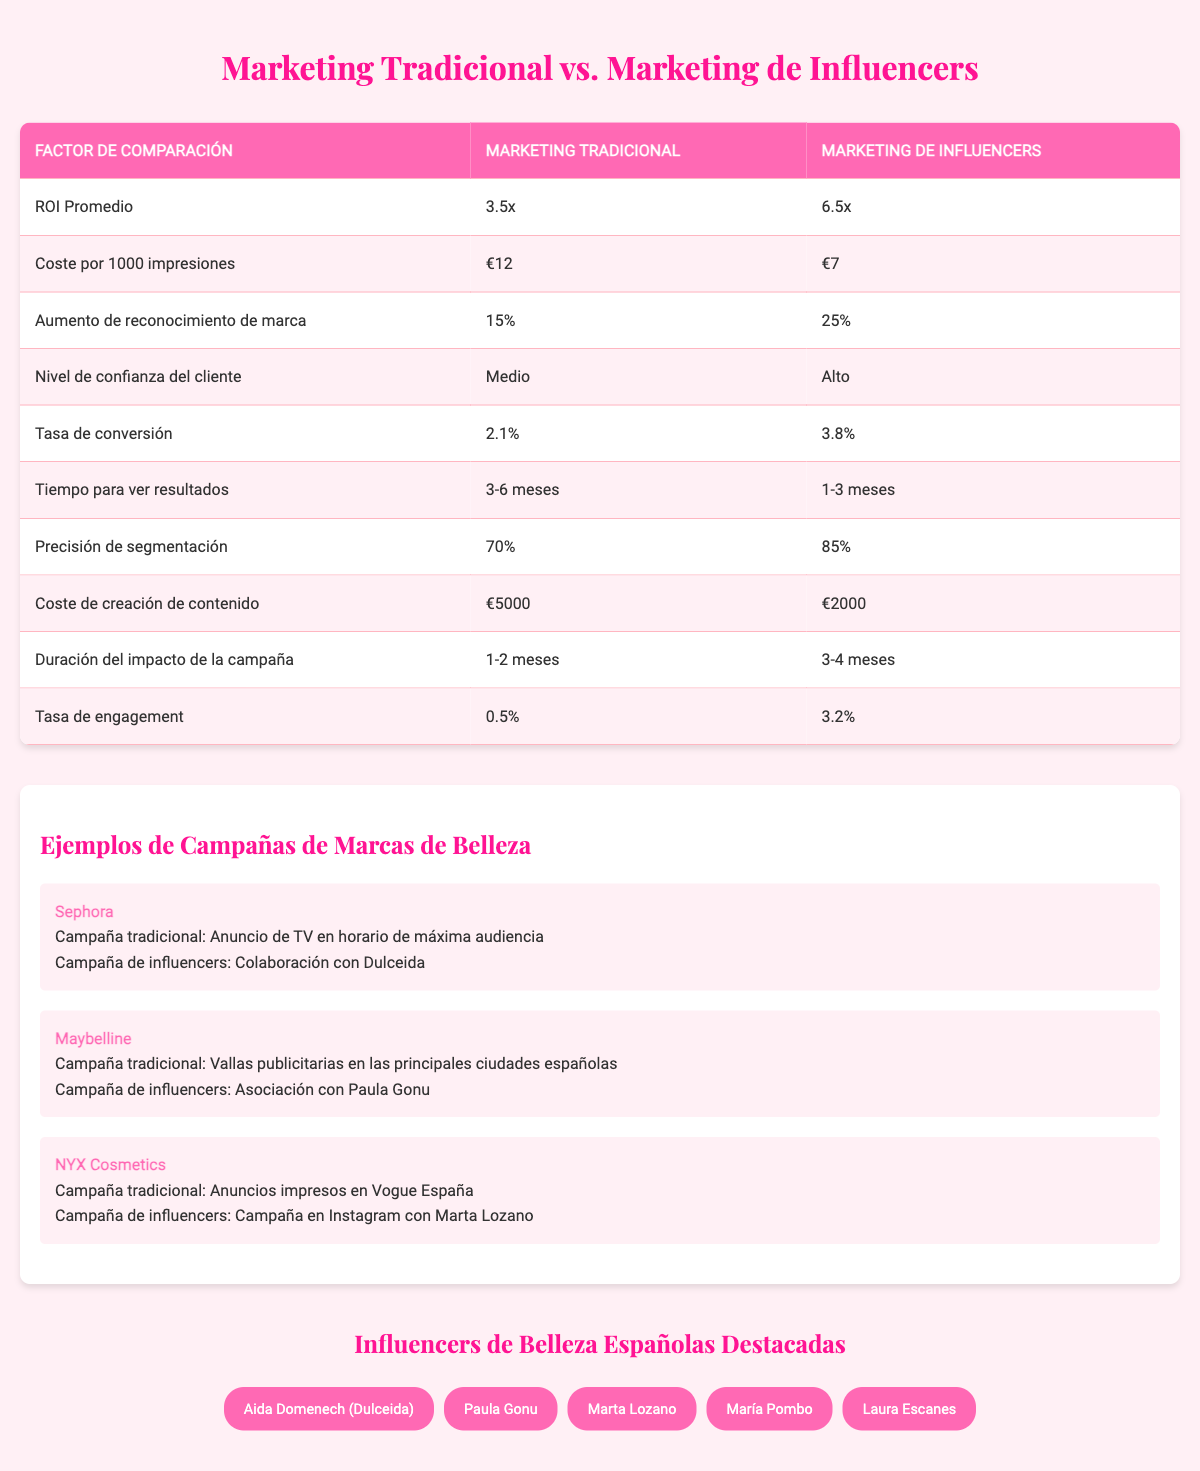What is the average ROI for traditional marketing? The table shows that the average ROI for traditional marketing is listed as 3.5x.
Answer: 3.5x What is the cost per 1000 impressions for influencer marketing? According to the table, the cost per 1000 impressions for influencer marketing is €7.
Answer: €7 What is the brand awareness increase for traditional marketing? The table indicates that the brand awareness increase associated with traditional marketing is 15%.
Answer: 15% Is the conversion rate higher for influencer marketing than for traditional marketing? By comparing the two values, influencer marketing has a conversion rate of 3.8%, while traditional marketing has 2.1%. Since 3.8% is higher than 2.1%, the answer is yes.
Answer: Yes Which marketing strategy has a higher customer trust level? The table shows that traditional marketing has a medium customer trust level, while influencer marketing has a high customer trust level. Thus, influencer marketing has a higher customer trust level.
Answer: Influencer marketing What is the time to see results for traditional marketing compared to influencer marketing? The table states that the time to see results for traditional marketing is 3-6 months, while for influencer marketing it is 1-3 months. This means that influencer marketing is faster to show results compared to traditional marketing.
Answer: Influencer marketing is faster Calculate the difference in average ROI between influencer marketing and traditional marketing. The average ROI for influencer marketing is 6.5x and for traditional marketing is 3.5x. To find the difference, subtract 3.5 from 6.5, which gives 3.0. So, the difference is 3.0.
Answer: 3.0 What is the engagement rate of traditional marketing? From the table, traditional marketing has an engagement rate of 0.5%.
Answer: 0.5% Which marketing type has a longer duration of impact? The duration of impact for traditional marketing is 1-2 months, while for influencer marketing it is 3-4 months. This shows that influencer marketing has a longer duration of impact.
Answer: Influencer marketing How does the cost of content creation compare between the two marketing strategies? The cost of content creation for traditional marketing is €5000, while for influencer marketing it is €2000. Therefore, influencer marketing is more cost-effective for content creation.
Answer: Influencer marketing is more cost-effective 